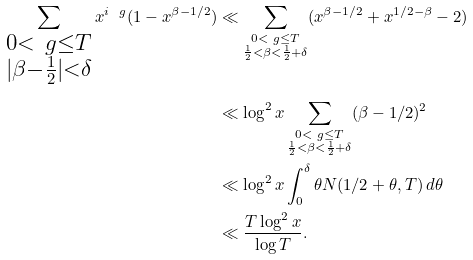<formula> <loc_0><loc_0><loc_500><loc_500>\sum _ { \substack { 0 < \ g \leq T \\ | \beta - \frac { 1 } { 2 } | < \delta } } x ^ { i \ g } ( 1 - x ^ { \beta - 1 / 2 } ) & \ll \sum _ { \substack { 0 < \ g \leq T \\ \frac { 1 } { 2 } < \beta < \frac { 1 } { 2 } + \delta } } ( x ^ { \beta - 1 / 2 } + x ^ { 1 / 2 - \beta } - 2 ) \\ & \ll \log ^ { 2 } x \sum _ { \substack { 0 < \ g \leq T \\ \frac { 1 } { 2 } < \beta < \frac { 1 } { 2 } + \delta } } ( \beta - 1 / 2 ) ^ { 2 } \\ & \ll \log ^ { 2 } x \int _ { 0 } ^ { \delta } \theta N ( 1 / 2 + \theta , T ) \, d \theta \\ & \ll \frac { T \log ^ { 2 } x } { \log T } .</formula> 